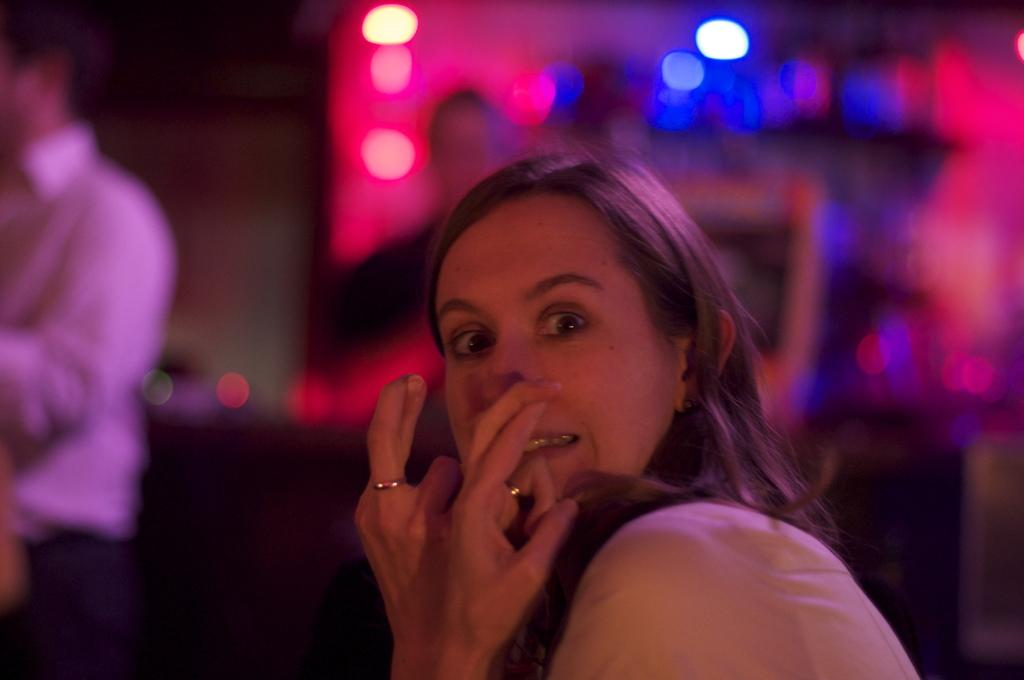Who is the main subject in the picture? There is a woman in the picture. What is the woman doing in the image? The woman is standing and giving a pose into the camera. How is the background depicted in the image? The background is blurred in the image. What can be observed about the background lighting? The background has some colorful spotlights. How many straws are being used by the chicken in the image? There is no chicken or straws present in the image. What type of division is being performed by the woman in the image? The woman is posing for a picture and not performing any division in the image. 